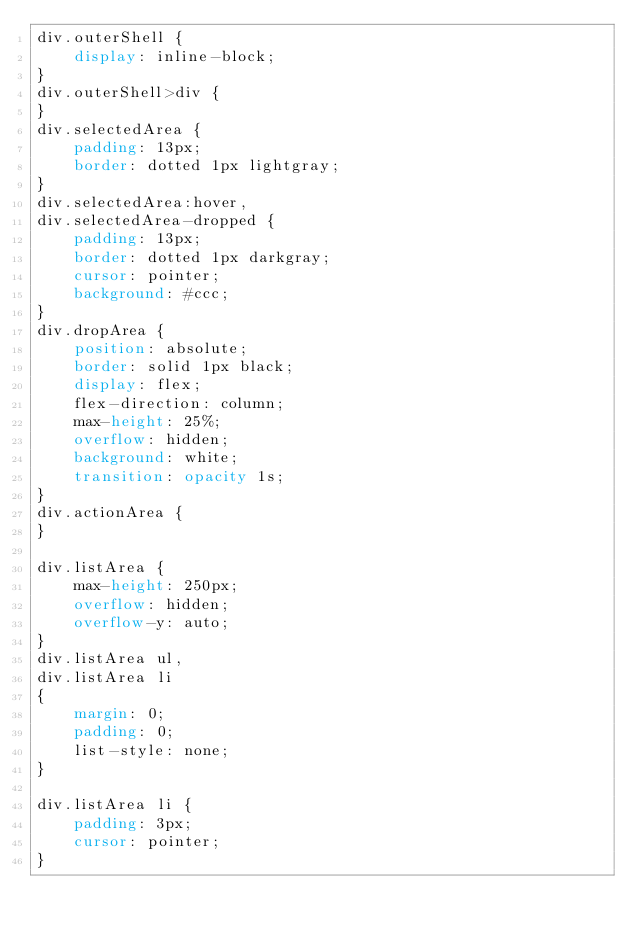<code> <loc_0><loc_0><loc_500><loc_500><_CSS_>div.outerShell {
    display: inline-block;
}
div.outerShell>div {
}
div.selectedArea {
    padding: 13px;
    border: dotted 1px lightgray;
}
div.selectedArea:hover,
div.selectedArea-dropped {
    padding: 13px;
    border: dotted 1px darkgray;
    cursor: pointer;
    background: #ccc;
}
div.dropArea {
    position: absolute;
    border: solid 1px black;
    display: flex;
    flex-direction: column;
    max-height: 25%;
    overflow: hidden;
    background: white;
    transition: opacity 1s;
}
div.actionArea {
}

div.listArea {
    max-height: 250px;
    overflow: hidden;
    overflow-y: auto;
}
div.listArea ul,
div.listArea li
{
    margin: 0;
    padding: 0;
    list-style: none;
}

div.listArea li {
    padding: 3px;
    cursor: pointer;
}

</code> 